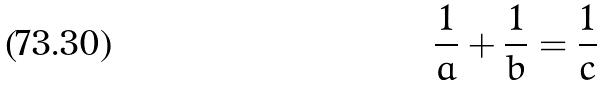Convert formula to latex. <formula><loc_0><loc_0><loc_500><loc_500>\frac { 1 } { a } + \frac { 1 } { b } = \frac { 1 } { c }</formula> 